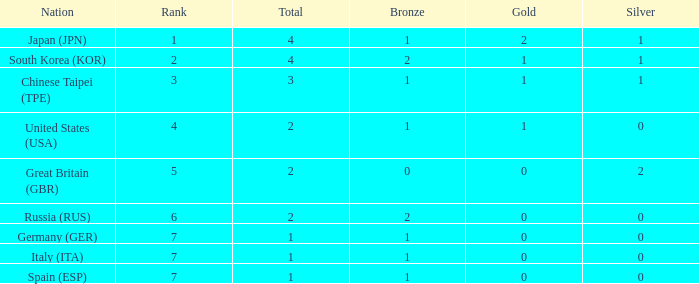What is the smallest number of gold of a country of rank 6, with 2 bronzes? None. 